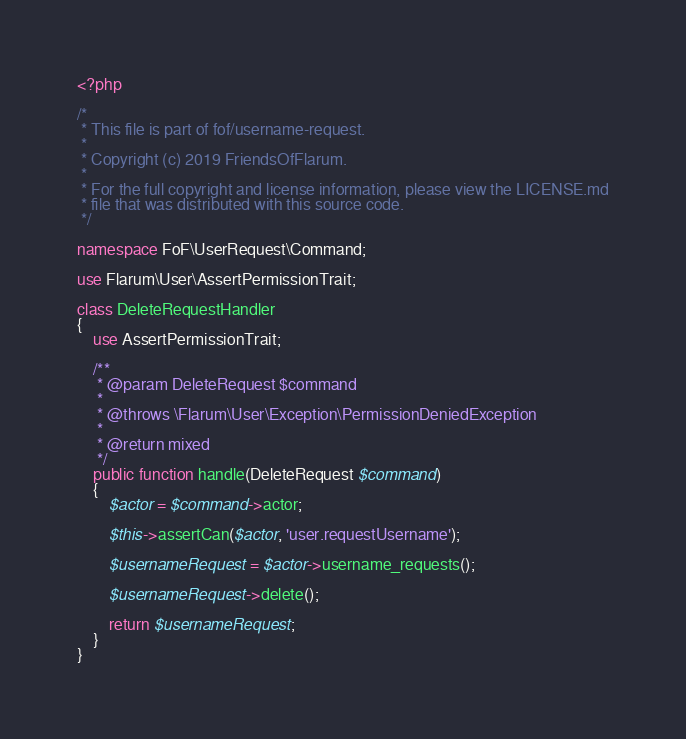<code> <loc_0><loc_0><loc_500><loc_500><_PHP_><?php

/*
 * This file is part of fof/username-request.
 *
 * Copyright (c) 2019 FriendsOfFlarum.
 *
 * For the full copyright and license information, please view the LICENSE.md
 * file that was distributed with this source code.
 */

namespace FoF\UserRequest\Command;

use Flarum\User\AssertPermissionTrait;

class DeleteRequestHandler
{
    use AssertPermissionTrait;

    /**
     * @param DeleteRequest $command
     *
     * @throws \Flarum\User\Exception\PermissionDeniedException
     *
     * @return mixed
     */
    public function handle(DeleteRequest $command)
    {
        $actor = $command->actor;

        $this->assertCan($actor, 'user.requestUsername');

        $usernameRequest = $actor->username_requests();

        $usernameRequest->delete();

        return $usernameRequest;
    }
}
</code> 